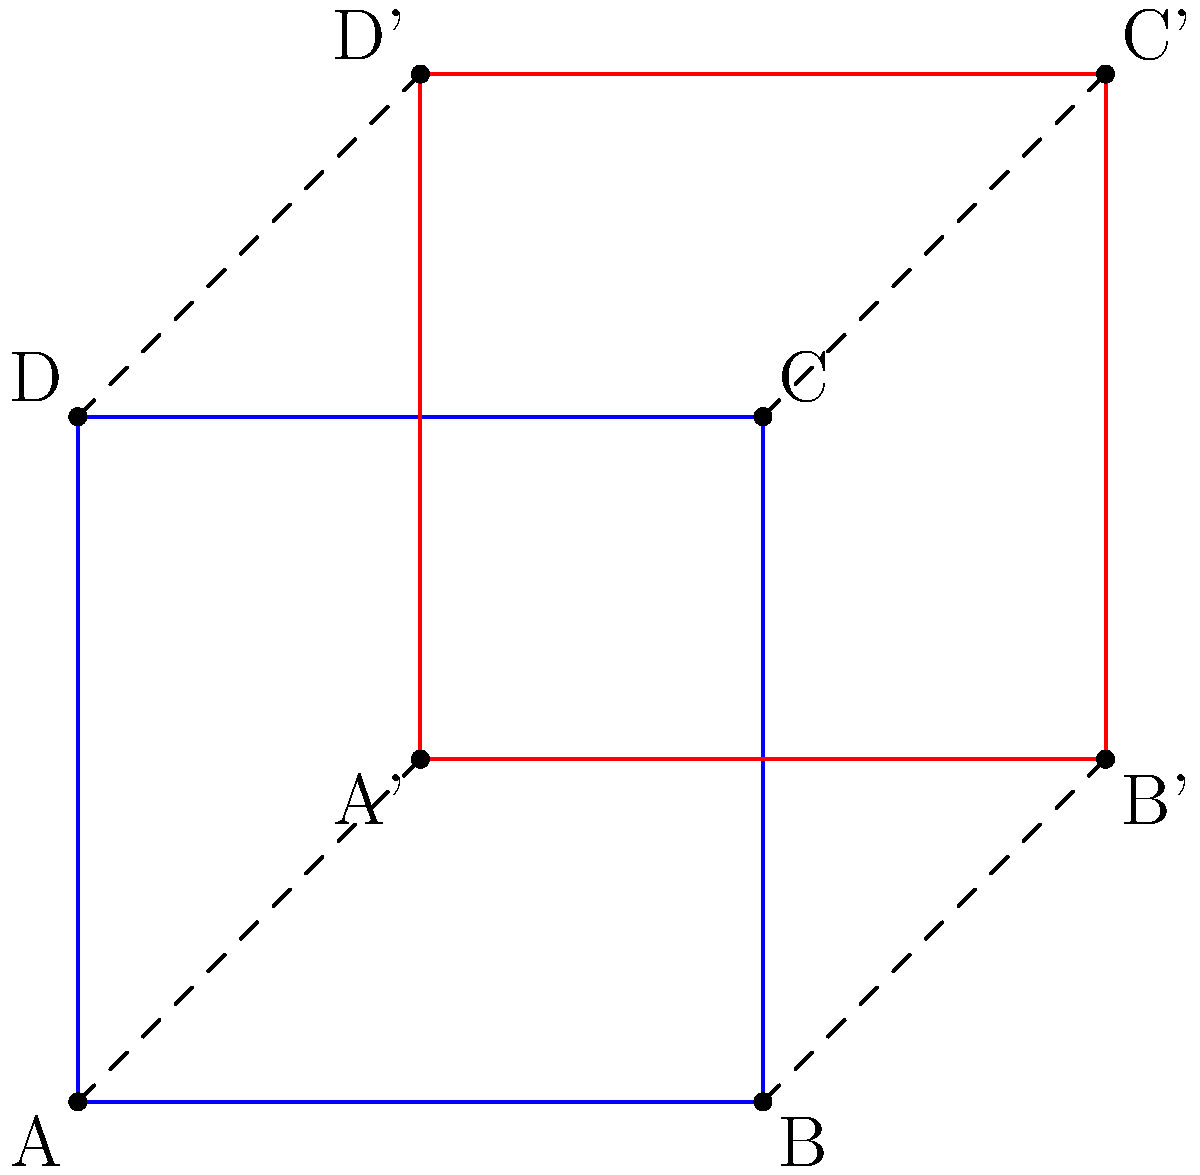In the context of animating a 2D object, what geometric transformation is represented by the movement from the blue square ABCD to the red square A'B'C'D', and how can it be described mathematically? To determine the geometric transformation, we need to analyze the relationship between the original blue square ABCD and the transformed red square A'B'C'D'. Let's follow these steps:

1. Observe the change in position:
   - Each point of the square has moved in the same direction and by the same amount.
   - The movement is 1 unit to the right and 1 unit up for all points.

2. Identify the transformation:
   - This uniform movement of all points is characteristic of a translation.

3. Describe the translation mathematically:
   - In 2D space, a translation can be represented by a vector $(t_x, t_y)$.
   - Here, $t_x = 1$ (1 unit right) and $t_y = 1$ (1 unit up).
   - The translation vector is therefore $(1, 1)$.

4. Express the transformation as a function:
   - For any point $(x, y)$ on the original square, its new position $(x', y')$ after the translation is:
     $x' = x + t_x = x + 1$
     $y' = y + t_y = y + 1$
   - This can be written as a transformation function:
     $T(x, y) = (x + 1, y + 1)$

5. Verify with a point:
   - For example, point A(0,0) becomes A'(1,1) after the translation.
   - Indeed, $T(0, 0) = (0 + 1, 0 + 1) = (1, 1)$

Therefore, the geometric transformation is a translation by the vector $(1, 1)$.
Answer: Translation by vector $(1, 1)$ 